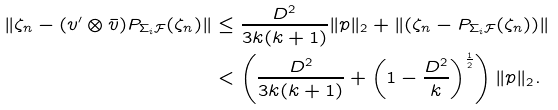Convert formula to latex. <formula><loc_0><loc_0><loc_500><loc_500>\| \zeta _ { n } - ( v ^ { \prime } \otimes \bar { v } ) P _ { \Sigma _ { i } \mathcal { F } } ( \zeta _ { n } ) \| & \leq \frac { D ^ { 2 } } { 3 k ( k + 1 ) } \| p \| _ { 2 } + \| ( \zeta _ { n } - P _ { \Sigma _ { i } \mathcal { F } } ( \zeta _ { n } ) ) \| \\ & < \left ( \frac { D ^ { 2 } } { 3 k ( k + 1 ) } + \left ( 1 - \frac { D ^ { 2 } } { k } \right ) ^ { \frac { 1 } { 2 } } \right ) \| p \| _ { 2 } .</formula> 